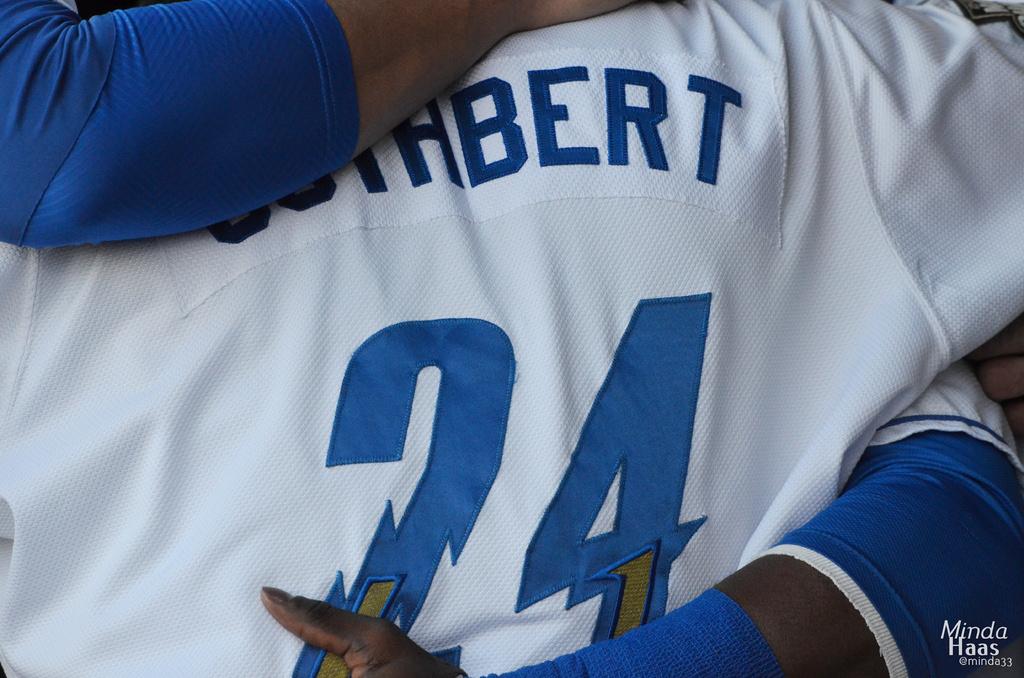What is the players name?
Ensure brevity in your answer.  Bert. 